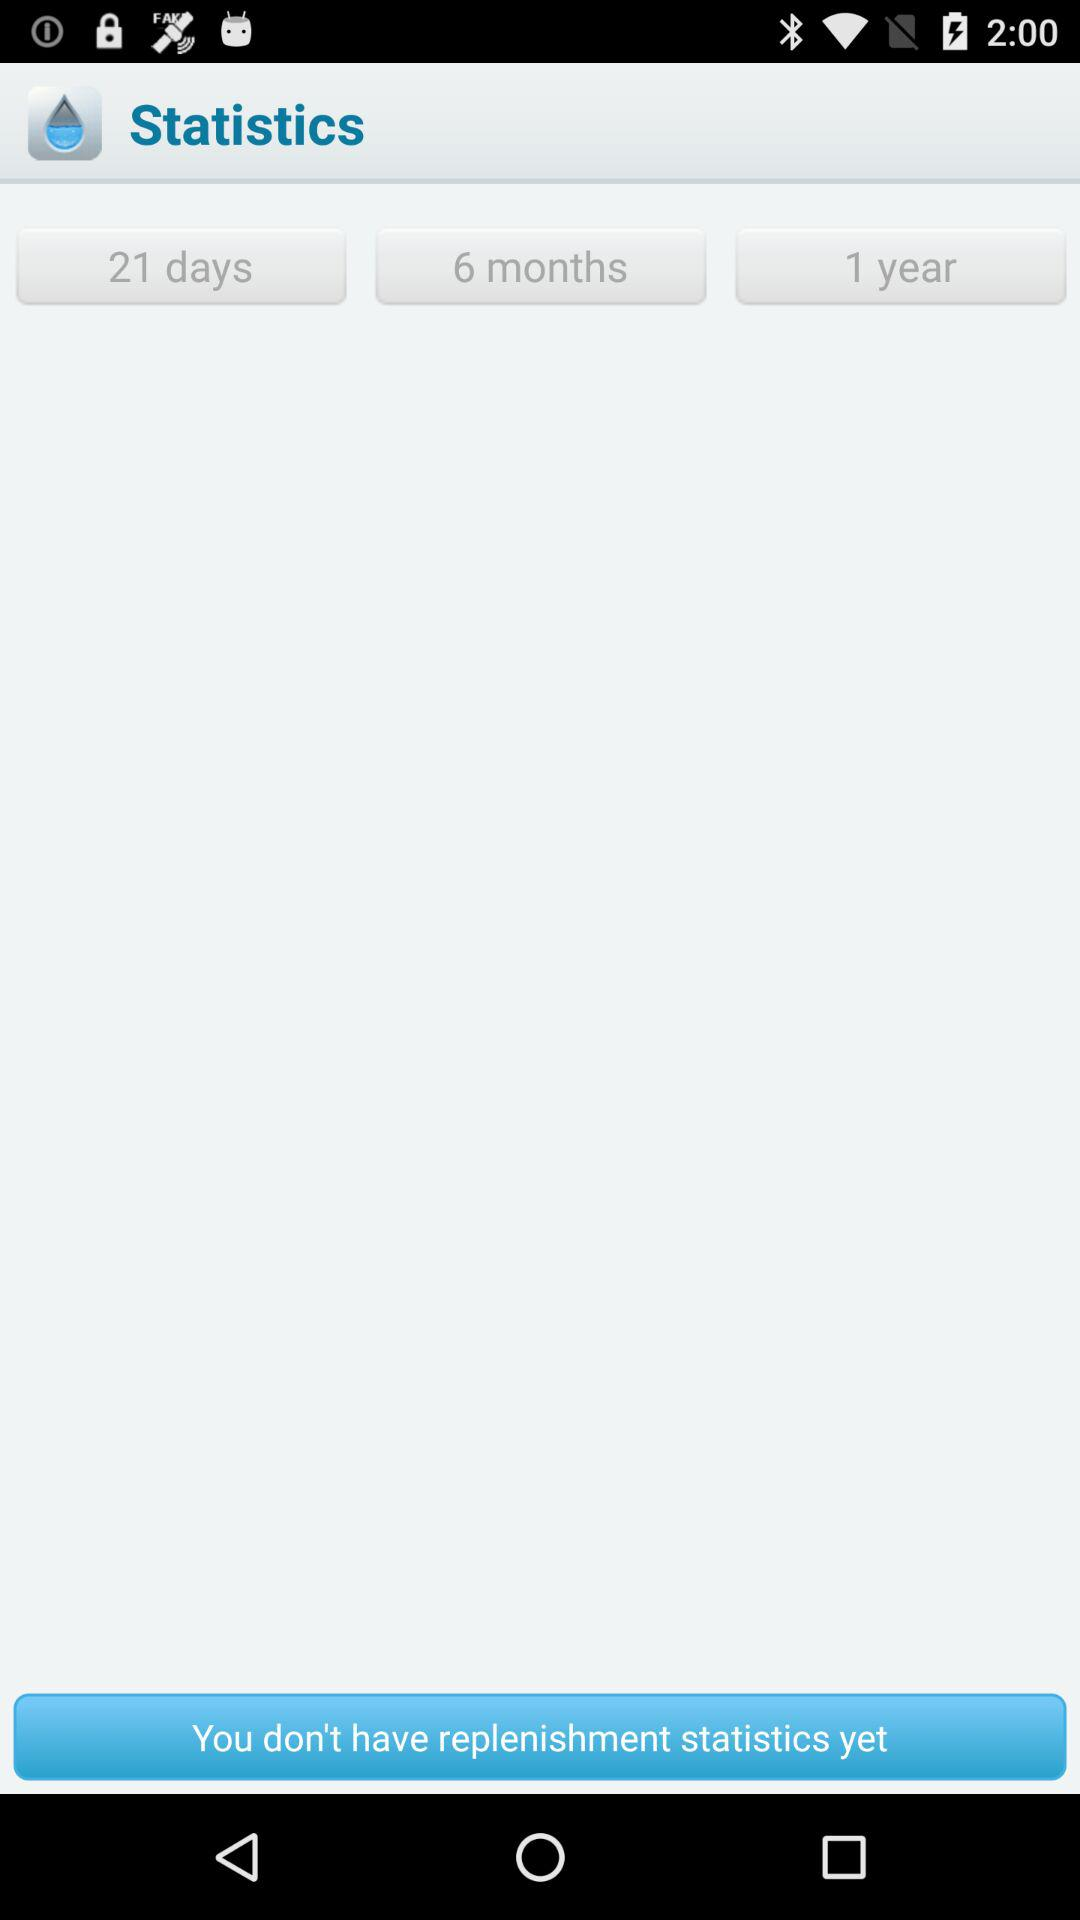What is the available option? The available options are "21 days", "6 months" and "1 year". 